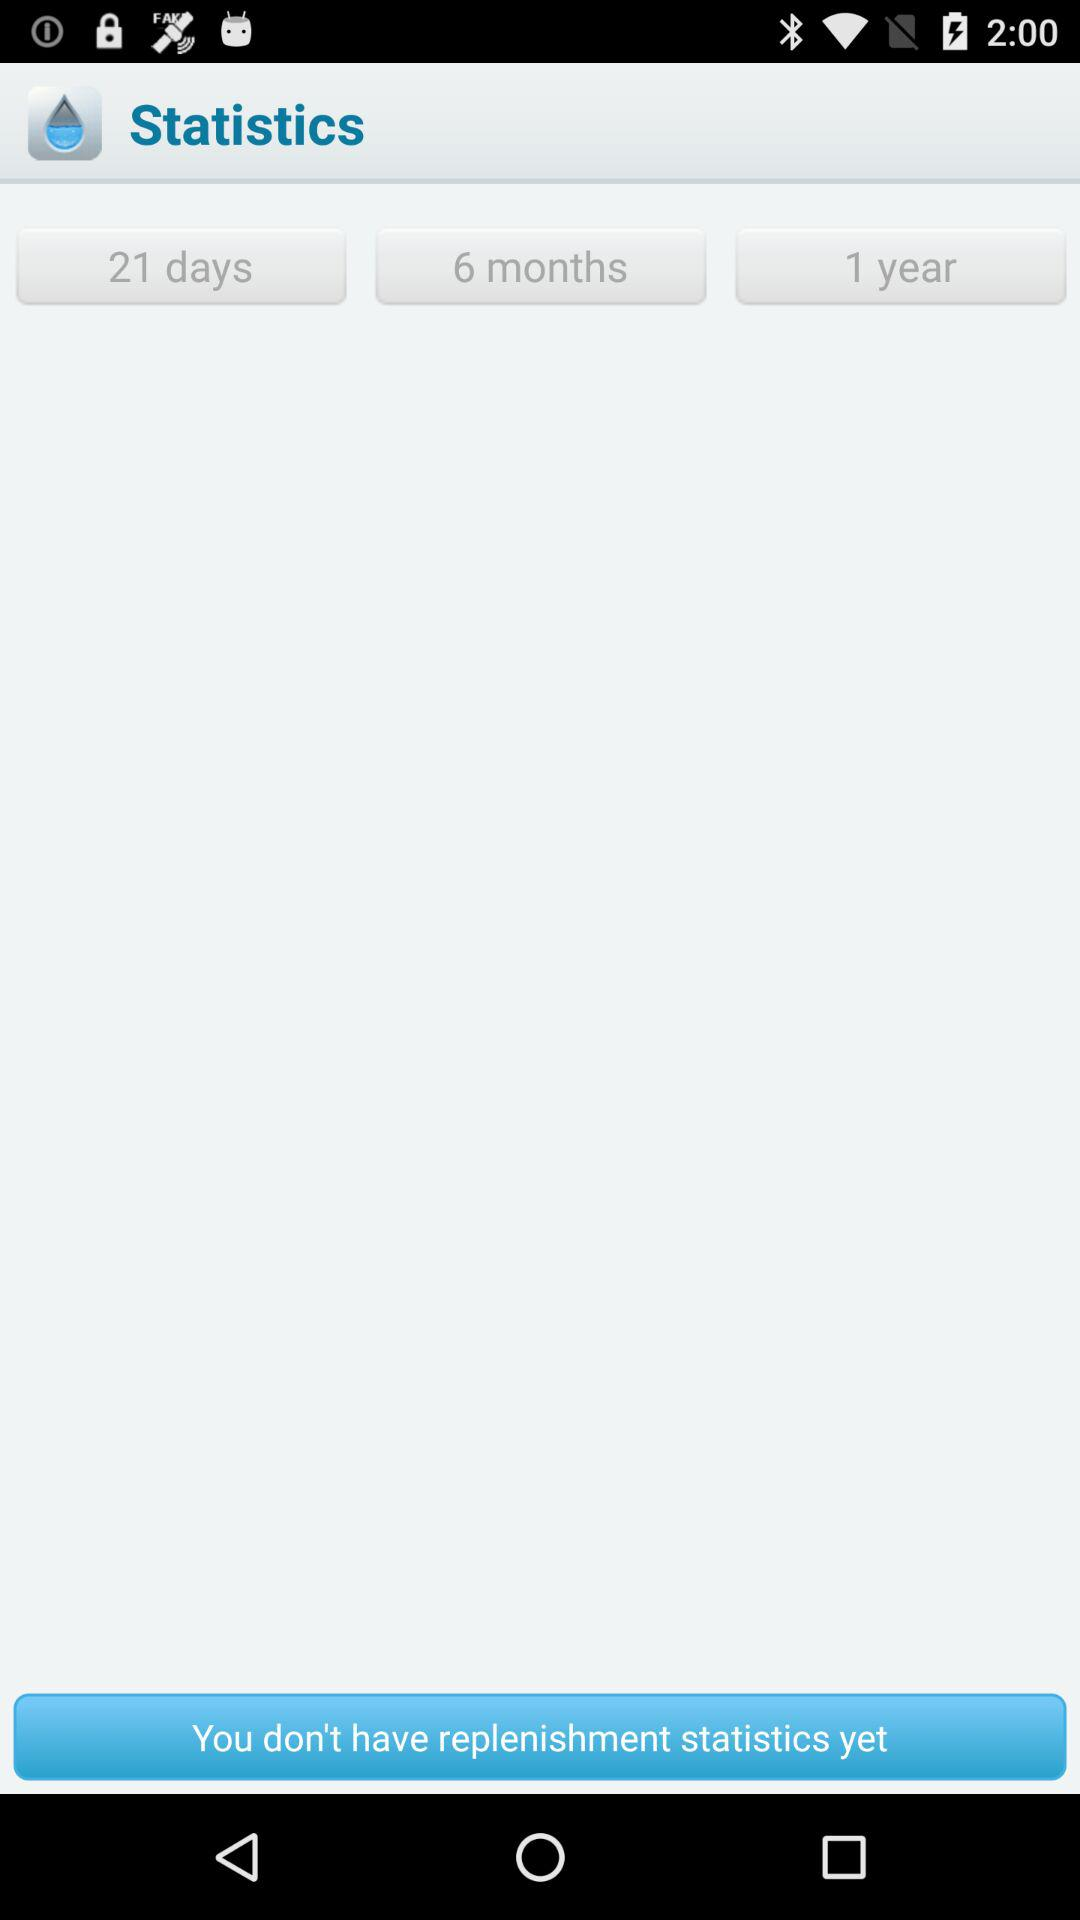What is the available option? The available options are "21 days", "6 months" and "1 year". 